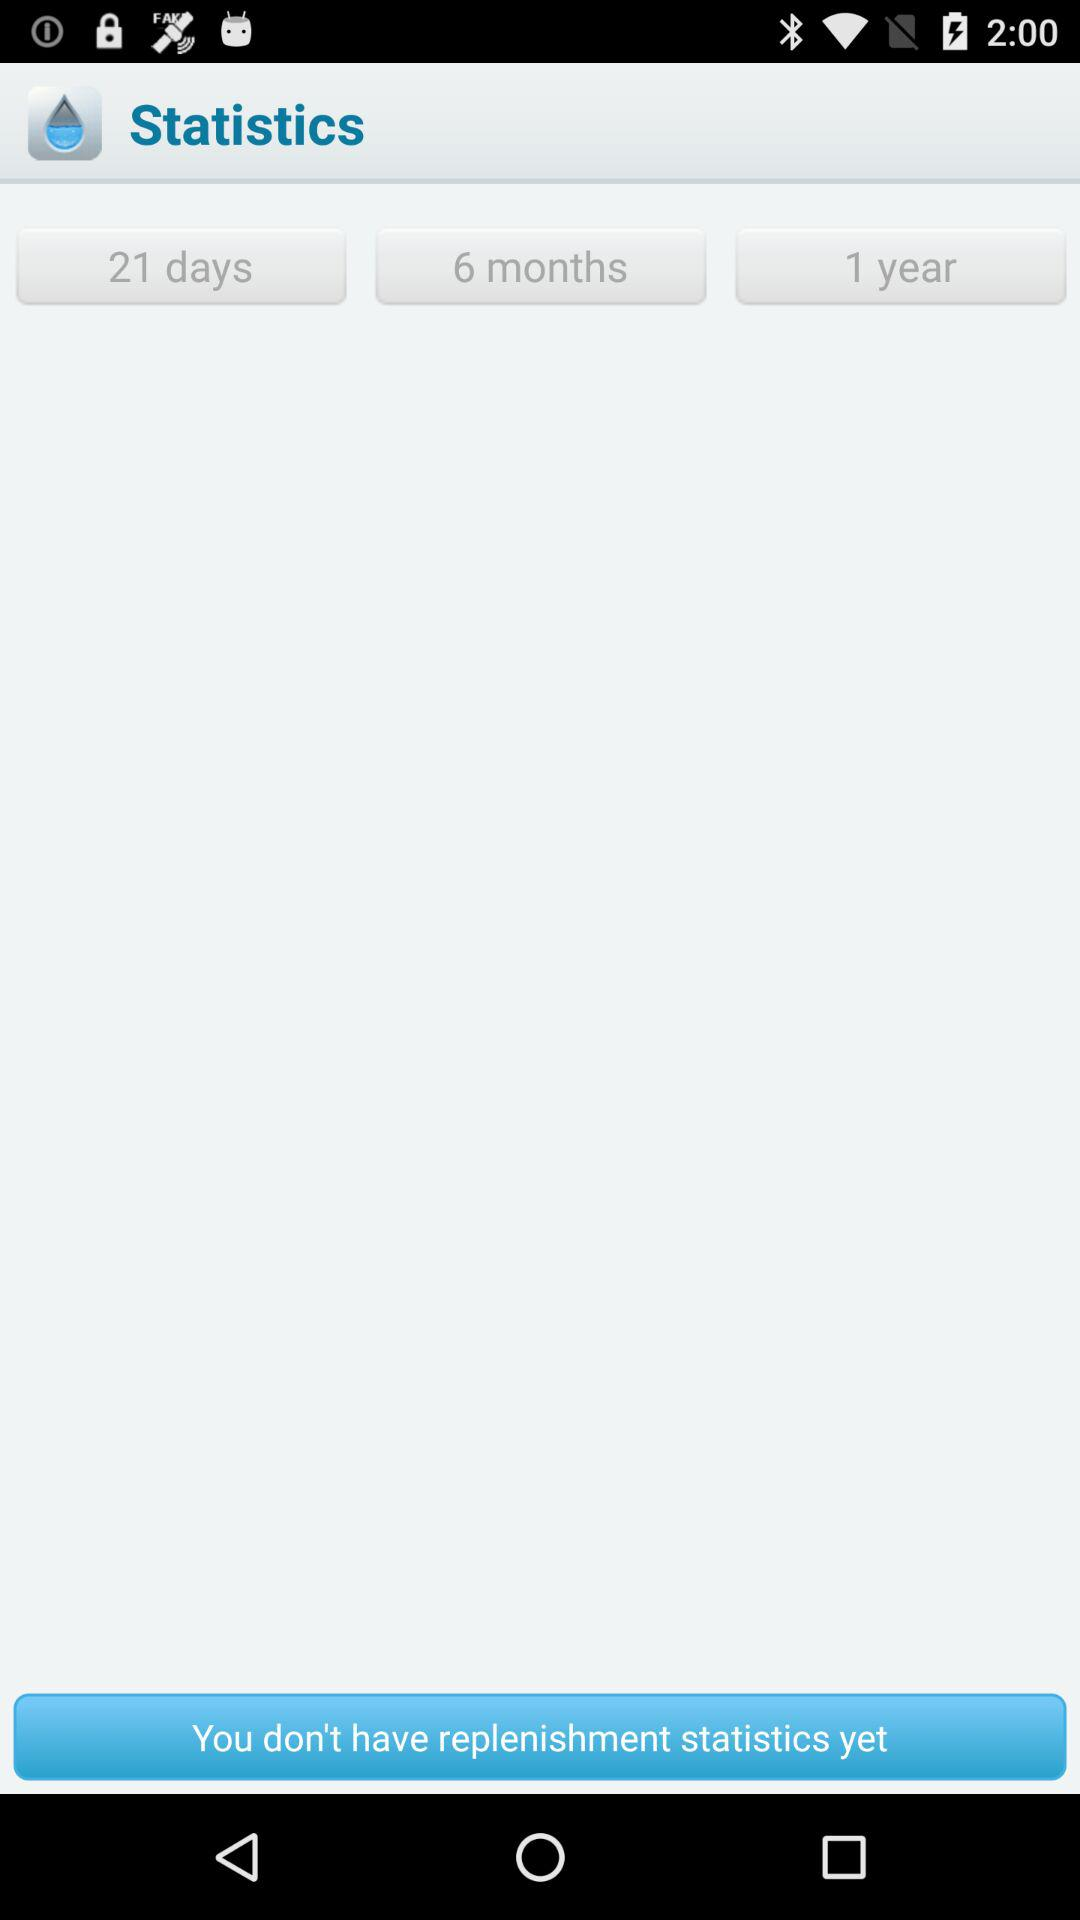What is the available option? The available options are "21 days", "6 months" and "1 year". 